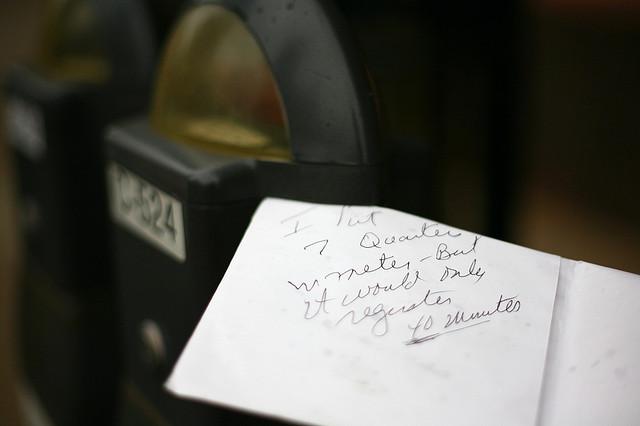What number is on the parking meter?
Write a very short answer. 524. What is the last word on the note?
Concise answer only. Minutes. What does the sticker say?
Answer briefly. C-524. What is written on the paper?
Quick response, please. Note to meter maid. 